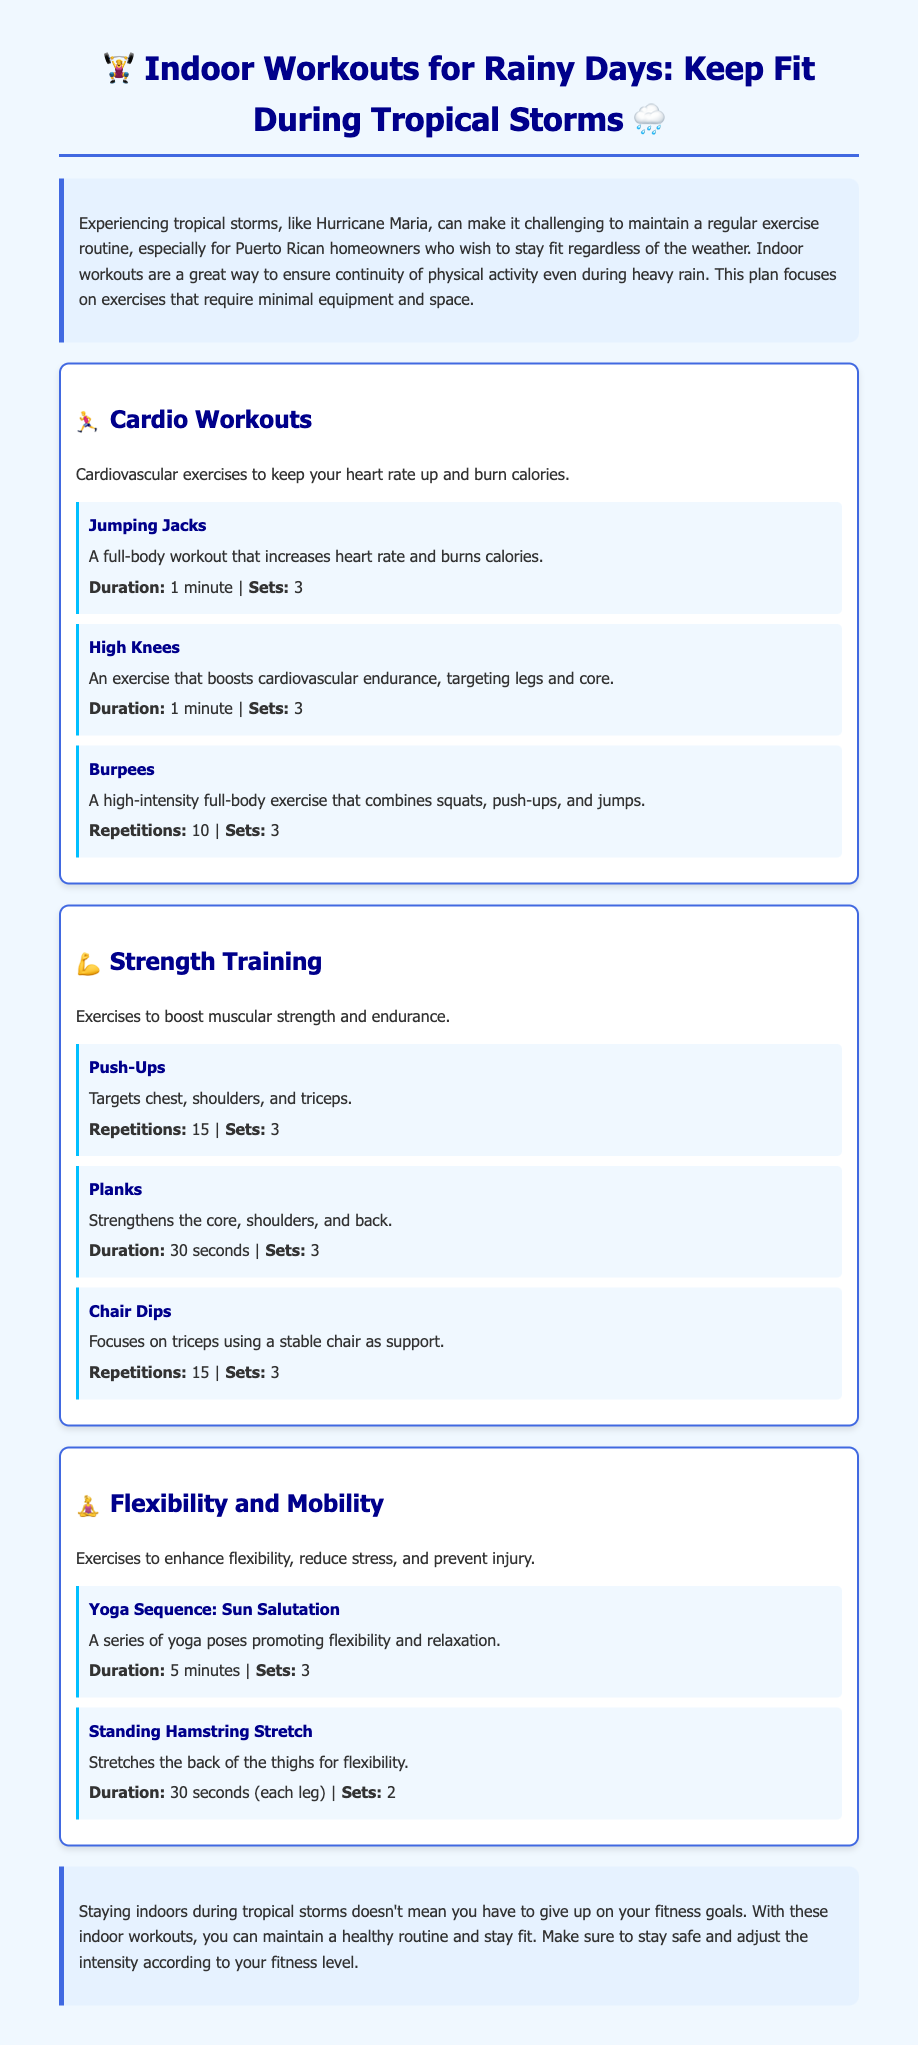What is the title of the workout plan? The title of the workout plan is present at the top of the document.
Answer: Indoor Workouts for Rainy Days: Keep Fit During Tropical Storms What are the three main workout categories? The categories are listed in the sections of the document.
Answer: Cardio Workouts, Strength Training, Flexibility and Mobility How long should each set of Jumping Jacks last? The duration is specified in the exercise section for Jumping Jacks.
Answer: 1 minute How many repetitions of Burpees are recommended? The number of repetitions is stated in the Burpees exercise description.
Answer: 10 What is the purpose of the Yoga Sequence: Sun Salutation? The purpose is described in the section for Flexibility and Mobility exercises.
Answer: Promoting flexibility and relaxation How many sets of Chair Dips should be performed? The number of sets is specified in the Chair Dips exercise section.
Answer: 3 What is a suitable duration for Standing Hamstring Stretch? The duration for the Standing Hamstring Stretch is mentioned in the exercise description.
Answer: 30 seconds (each leg) What is the main focus of the Strength Training category? The main focus is mentioned in the introduction to the Strength Training section.
Answer: Boost muscular strength and endurance How should one adjust the workout intensity? The document suggests how to adjust intensity at the end.
Answer: According to your fitness level 